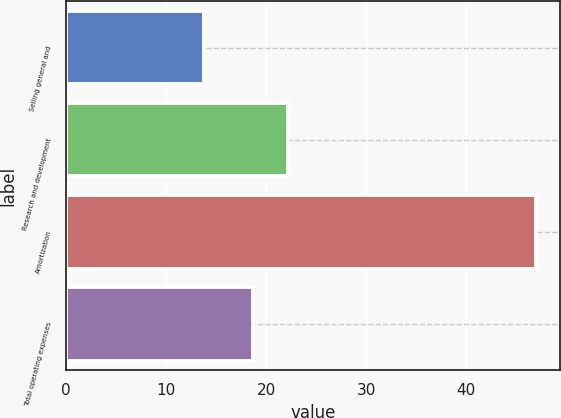Convert chart. <chart><loc_0><loc_0><loc_500><loc_500><bar_chart><fcel>Selling general and<fcel>Research and development<fcel>Amortization<fcel>Total operating expenses<nl><fcel>13.8<fcel>22.2<fcel>47<fcel>18.7<nl></chart> 